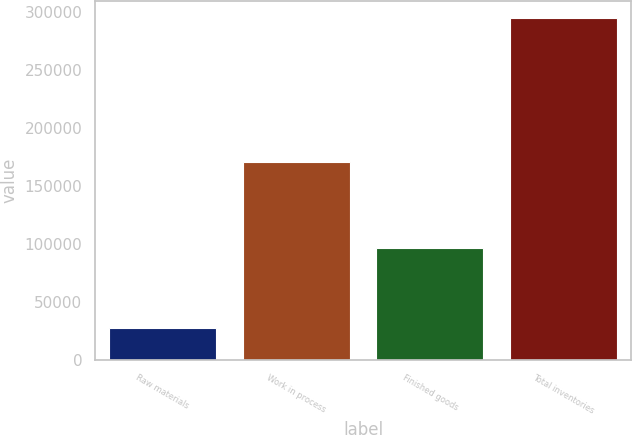Convert chart. <chart><loc_0><loc_0><loc_500><loc_500><bar_chart><fcel>Raw materials<fcel>Work in process<fcel>Finished goods<fcel>Total inventories<nl><fcel>28085<fcel>170398<fcel>96598<fcel>295081<nl></chart> 